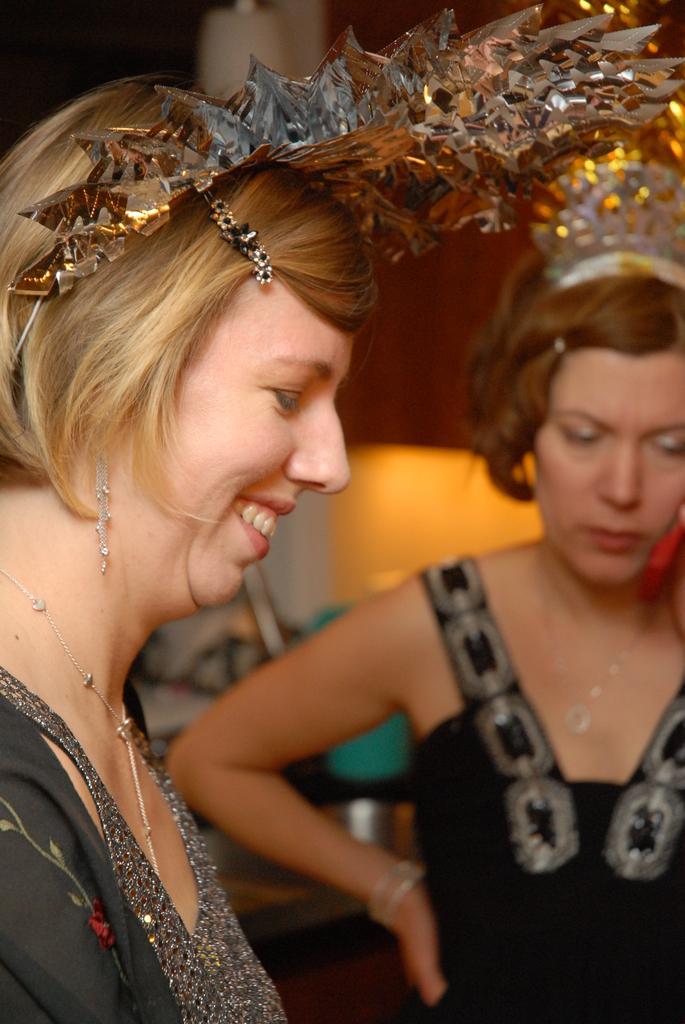Can you describe this image briefly? In this image I can see two people with black and grey color dresses. I can see these people with crowns. And there is a blurred background. 